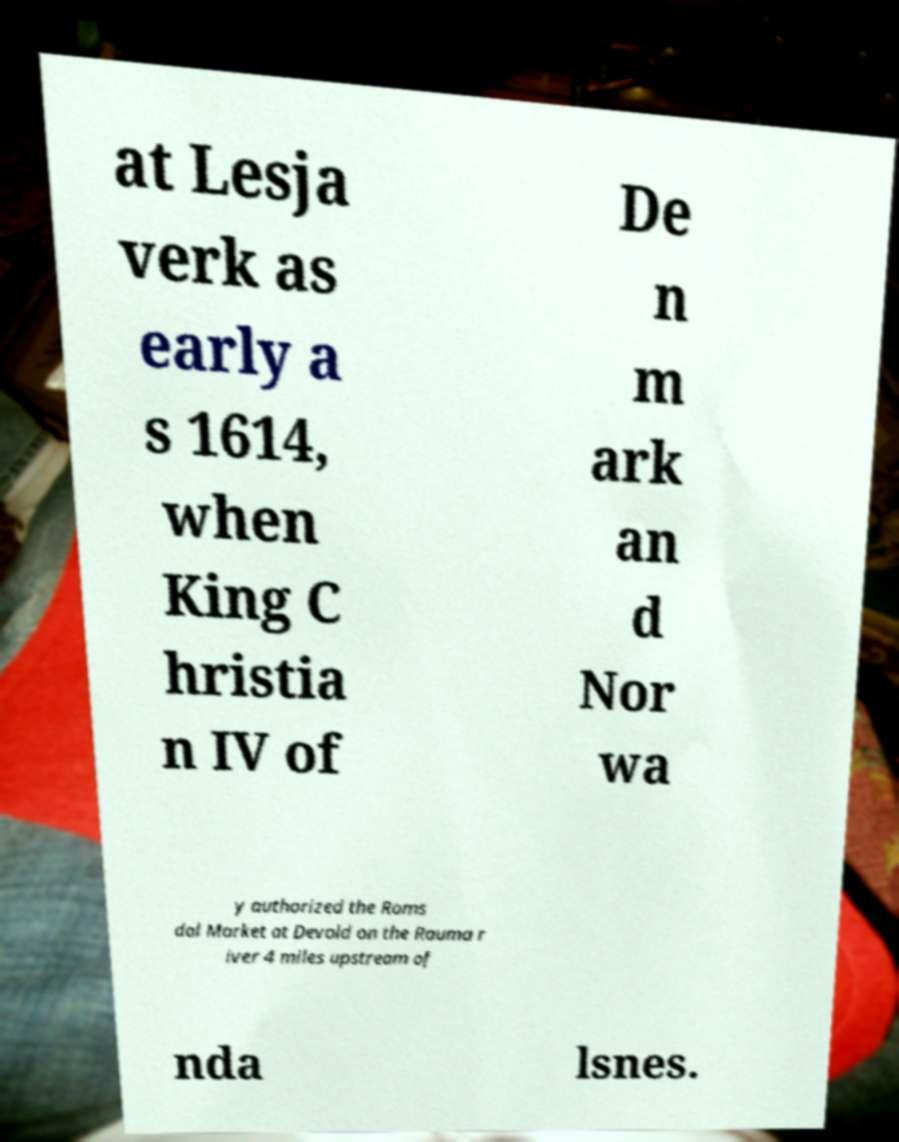Can you accurately transcribe the text from the provided image for me? at Lesja verk as early a s 1614, when King C hristia n IV of De n m ark an d Nor wa y authorized the Roms dal Market at Devold on the Rauma r iver 4 miles upstream of nda lsnes. 